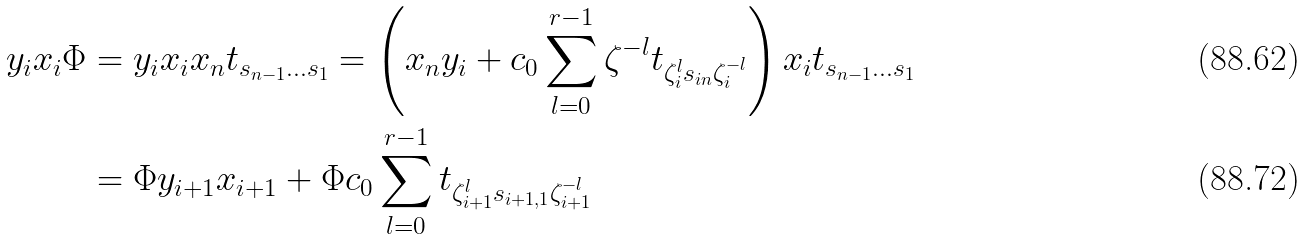<formula> <loc_0><loc_0><loc_500><loc_500>y _ { i } x _ { i } \Phi & = y _ { i } x _ { i } x _ { n } t _ { s _ { n - 1 } \dots s _ { 1 } } = \left ( x _ { n } y _ { i } + c _ { 0 } \sum _ { l = 0 } ^ { r - 1 } \zeta ^ { - l } t _ { \zeta _ { i } ^ { l } s _ { i n } \zeta _ { i } ^ { - l } } \right ) x _ { i } t _ { s _ { n - 1 } \dots s _ { 1 } } \\ & = \Phi y _ { i + 1 } x _ { i + 1 } + \Phi c _ { 0 } \sum _ { l = 0 } ^ { r - 1 } t _ { \zeta _ { i + 1 } ^ { l } s _ { i + 1 , 1 } \zeta _ { i + 1 } ^ { - l } }</formula> 